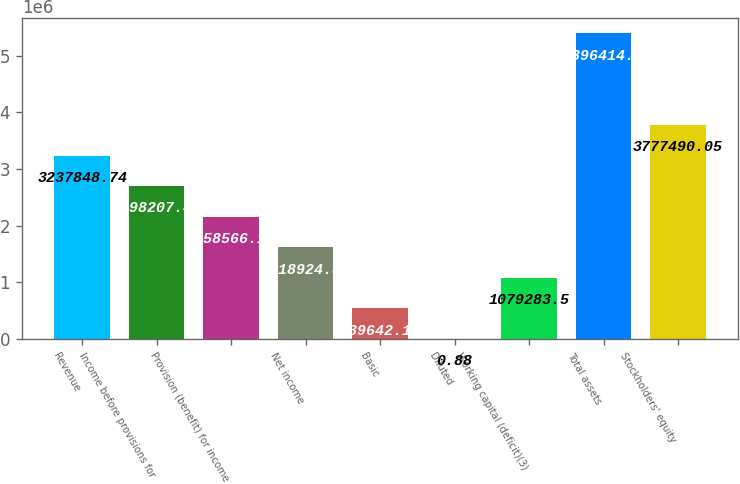Convert chart. <chart><loc_0><loc_0><loc_500><loc_500><bar_chart><fcel>Revenue<fcel>Income before provisions for<fcel>Provision (benefit) for income<fcel>Net income<fcel>Basic<fcel>Diluted<fcel>Working capital (deficit)(3)<fcel>Total assets<fcel>Stockholders' equity<nl><fcel>3.23785e+06<fcel>2.69821e+06<fcel>2.15857e+06<fcel>1.61892e+06<fcel>539642<fcel>0.88<fcel>1.07928e+06<fcel>5.39641e+06<fcel>3.77749e+06<nl></chart> 